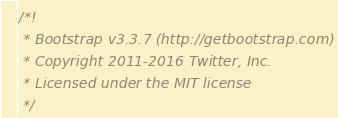<code> <loc_0><loc_0><loc_500><loc_500><_JavaScript_>/*!
 * Bootstrap v3.3.7 (http://getbootstrap.com)
 * Copyright 2011-2016 Twitter, Inc.
 * Licensed under the MIT license
 */</code> 